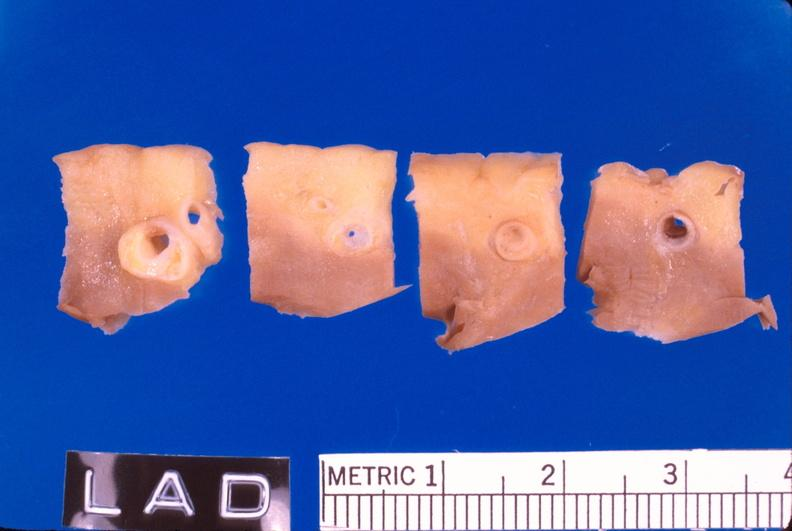s cardiovascular present?
Answer the question using a single word or phrase. Yes 